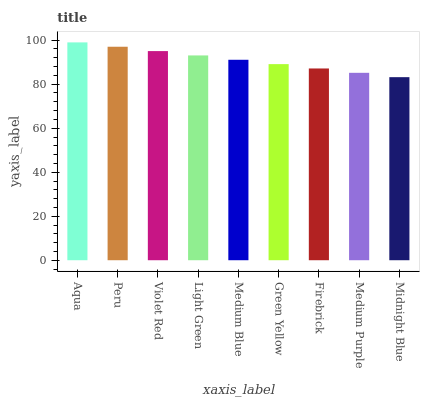Is Midnight Blue the minimum?
Answer yes or no. Yes. Is Aqua the maximum?
Answer yes or no. Yes. Is Peru the minimum?
Answer yes or no. No. Is Peru the maximum?
Answer yes or no. No. Is Aqua greater than Peru?
Answer yes or no. Yes. Is Peru less than Aqua?
Answer yes or no. Yes. Is Peru greater than Aqua?
Answer yes or no. No. Is Aqua less than Peru?
Answer yes or no. No. Is Medium Blue the high median?
Answer yes or no. Yes. Is Medium Blue the low median?
Answer yes or no. Yes. Is Medium Purple the high median?
Answer yes or no. No. Is Aqua the low median?
Answer yes or no. No. 